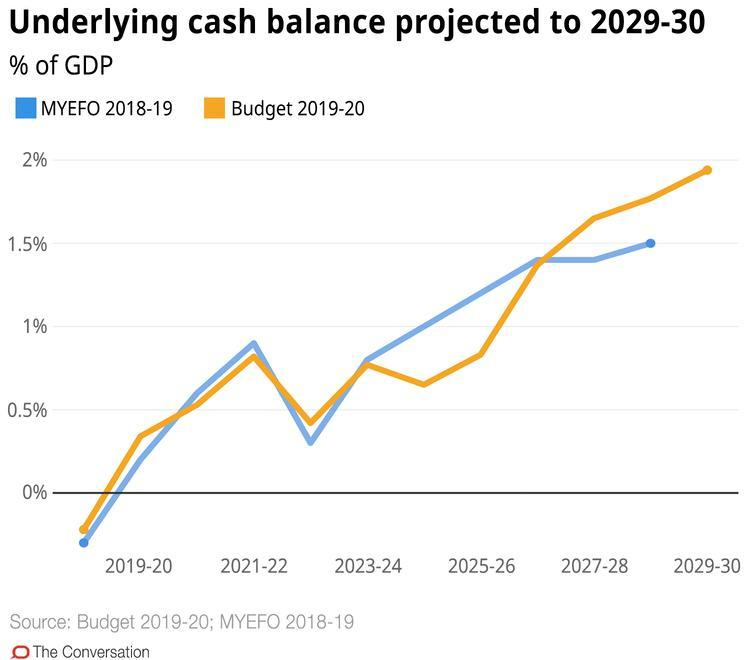What colour is the line corresponding to MYEFO 2018-19- orange, blue or red?
Answer the question with a short phrase. blue What does orange line signify? Budget 2019-20 When will underlying cash balance for Budget 2019-20 be highest? 2029-30 